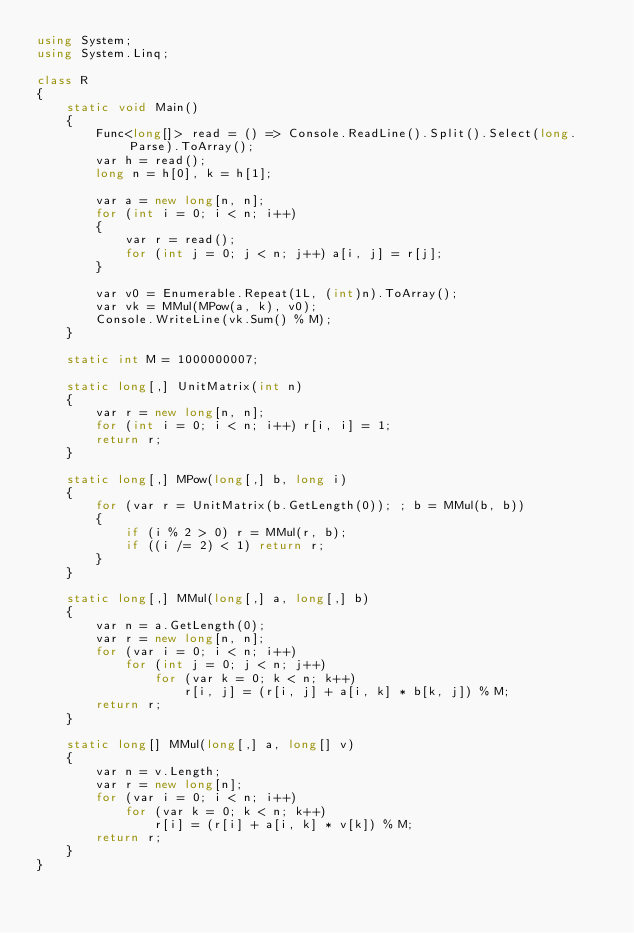<code> <loc_0><loc_0><loc_500><loc_500><_C#_>using System;
using System.Linq;

class R
{
	static void Main()
	{
		Func<long[]> read = () => Console.ReadLine().Split().Select(long.Parse).ToArray();
		var h = read();
		long n = h[0], k = h[1];

		var a = new long[n, n];
		for (int i = 0; i < n; i++)
		{
			var r = read();
			for (int j = 0; j < n; j++) a[i, j] = r[j];
		}

		var v0 = Enumerable.Repeat(1L, (int)n).ToArray();
		var vk = MMul(MPow(a, k), v0);
		Console.WriteLine(vk.Sum() % M);
	}

	static int M = 1000000007;

	static long[,] UnitMatrix(int n)
	{
		var r = new long[n, n];
		for (int i = 0; i < n; i++) r[i, i] = 1;
		return r;
	}

	static long[,] MPow(long[,] b, long i)
	{
		for (var r = UnitMatrix(b.GetLength(0)); ; b = MMul(b, b))
		{
			if (i % 2 > 0) r = MMul(r, b);
			if ((i /= 2) < 1) return r;
		}
	}

	static long[,] MMul(long[,] a, long[,] b)
	{
		var n = a.GetLength(0);
		var r = new long[n, n];
		for (var i = 0; i < n; i++)
			for (int j = 0; j < n; j++)
				for (var k = 0; k < n; k++)
					r[i, j] = (r[i, j] + a[i, k] * b[k, j]) % M;
		return r;
	}

	static long[] MMul(long[,] a, long[] v)
	{
		var n = v.Length;
		var r = new long[n];
		for (var i = 0; i < n; i++)
			for (var k = 0; k < n; k++)
				r[i] = (r[i] + a[i, k] * v[k]) % M;
		return r;
	}
}
</code> 